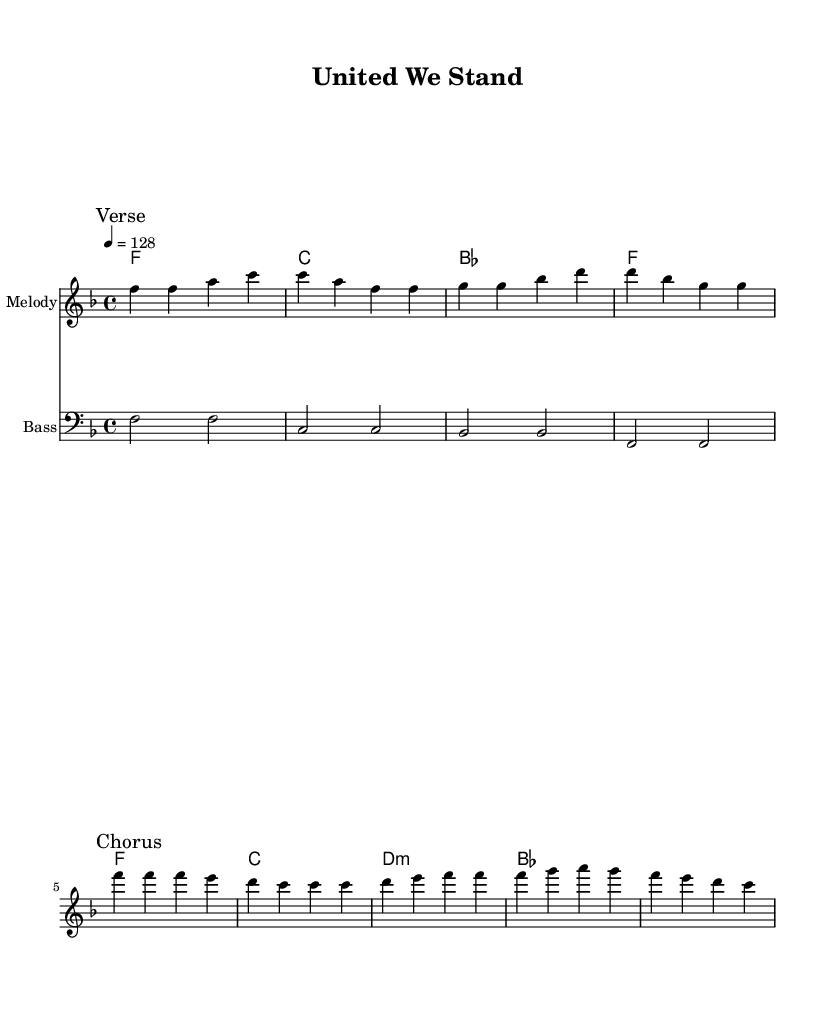What is the key signature of this music? The key signature indicates that the music is in F major, which has one flat (B flat). This can be determined by checking for the key symbols or the overall context usually indicated at the beginning of the staff.
Answer: F major What is the time signature of this piece? The time signature is 4/4, which means there are four beats in a measure and a quarter note receives one beat. This is typically noted at the beginning of the staff.
Answer: 4/4 What is the tempo marking for the music? The tempo marking indicates that the music should be played at a speed of 128 beats per minute, which gives it an upbeat feel suitable for dance music. This is noted in the tempo indication part of the score.
Answer: 128 What is the first note of the melody? The first note of the melody is F. This can be identified by looking at the first note in the melody staff in the sheet music.
Answer: F How many bars are there in the chorus section? The chorus section contains 4 bars, as indicated by the measures in the score. Counting the measure lines specifically marked as "Chorus" gives the total.
Answer: 4 What type of chords are used in the harmonies? The chords used include major and a minor chord (d minor), which is characteristic of upbeat electronic dance music. Identifying the chord symbols in the harmony staff reveals their types.
Answer: Major and minor 